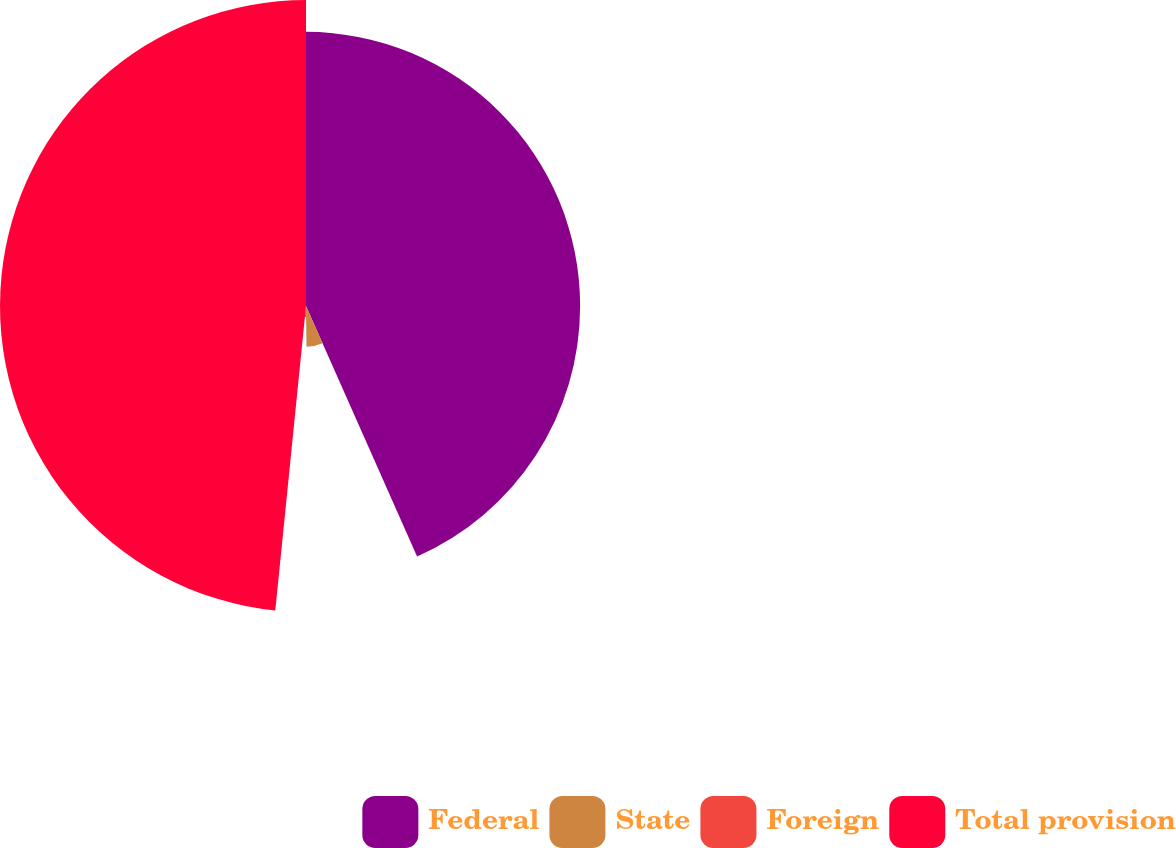Convert chart. <chart><loc_0><loc_0><loc_500><loc_500><pie_chart><fcel>Federal<fcel>State<fcel>Foreign<fcel>Total provision<nl><fcel>43.36%<fcel>6.45%<fcel>1.79%<fcel>48.4%<nl></chart> 